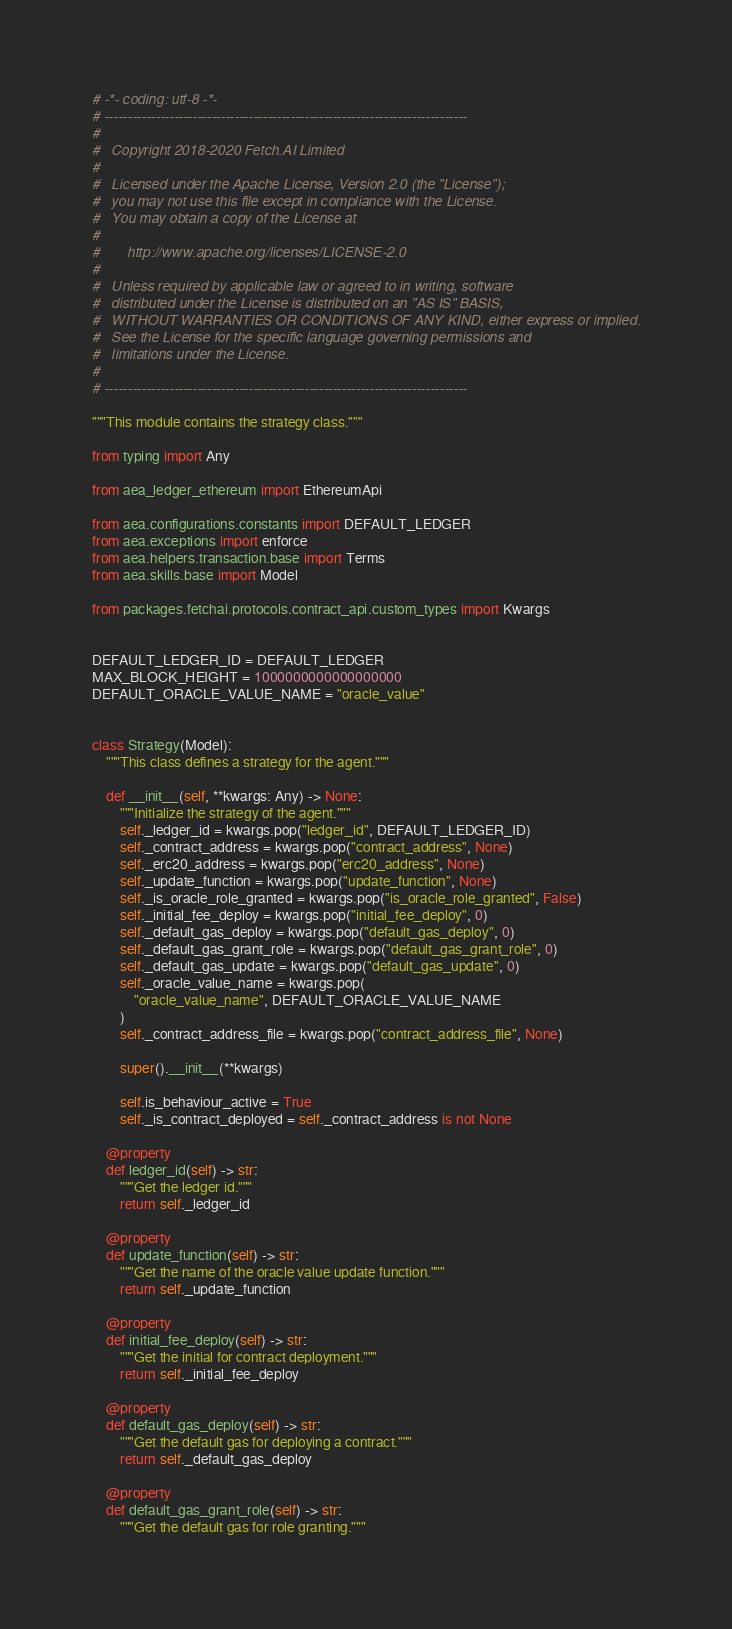Convert code to text. <code><loc_0><loc_0><loc_500><loc_500><_Python_># -*- coding: utf-8 -*-
# ------------------------------------------------------------------------------
#
#   Copyright 2018-2020 Fetch.AI Limited
#
#   Licensed under the Apache License, Version 2.0 (the "License");
#   you may not use this file except in compliance with the License.
#   You may obtain a copy of the License at
#
#       http://www.apache.org/licenses/LICENSE-2.0
#
#   Unless required by applicable law or agreed to in writing, software
#   distributed under the License is distributed on an "AS IS" BASIS,
#   WITHOUT WARRANTIES OR CONDITIONS OF ANY KIND, either express or implied.
#   See the License for the specific language governing permissions and
#   limitations under the License.
#
# ------------------------------------------------------------------------------

"""This module contains the strategy class."""

from typing import Any

from aea_ledger_ethereum import EthereumApi

from aea.configurations.constants import DEFAULT_LEDGER
from aea.exceptions import enforce
from aea.helpers.transaction.base import Terms
from aea.skills.base import Model

from packages.fetchai.protocols.contract_api.custom_types import Kwargs


DEFAULT_LEDGER_ID = DEFAULT_LEDGER
MAX_BLOCK_HEIGHT = 1000000000000000000
DEFAULT_ORACLE_VALUE_NAME = "oracle_value"


class Strategy(Model):
    """This class defines a strategy for the agent."""

    def __init__(self, **kwargs: Any) -> None:
        """Initialize the strategy of the agent."""
        self._ledger_id = kwargs.pop("ledger_id", DEFAULT_LEDGER_ID)
        self._contract_address = kwargs.pop("contract_address", None)
        self._erc20_address = kwargs.pop("erc20_address", None)
        self._update_function = kwargs.pop("update_function", None)
        self._is_oracle_role_granted = kwargs.pop("is_oracle_role_granted", False)
        self._initial_fee_deploy = kwargs.pop("initial_fee_deploy", 0)
        self._default_gas_deploy = kwargs.pop("default_gas_deploy", 0)
        self._default_gas_grant_role = kwargs.pop("default_gas_grant_role", 0)
        self._default_gas_update = kwargs.pop("default_gas_update", 0)
        self._oracle_value_name = kwargs.pop(
            "oracle_value_name", DEFAULT_ORACLE_VALUE_NAME
        )
        self._contract_address_file = kwargs.pop("contract_address_file", None)

        super().__init__(**kwargs)

        self.is_behaviour_active = True
        self._is_contract_deployed = self._contract_address is not None

    @property
    def ledger_id(self) -> str:
        """Get the ledger id."""
        return self._ledger_id

    @property
    def update_function(self) -> str:
        """Get the name of the oracle value update function."""
        return self._update_function

    @property
    def initial_fee_deploy(self) -> str:
        """Get the initial for contract deployment."""
        return self._initial_fee_deploy

    @property
    def default_gas_deploy(self) -> str:
        """Get the default gas for deploying a contract."""
        return self._default_gas_deploy

    @property
    def default_gas_grant_role(self) -> str:
        """Get the default gas for role granting."""</code> 